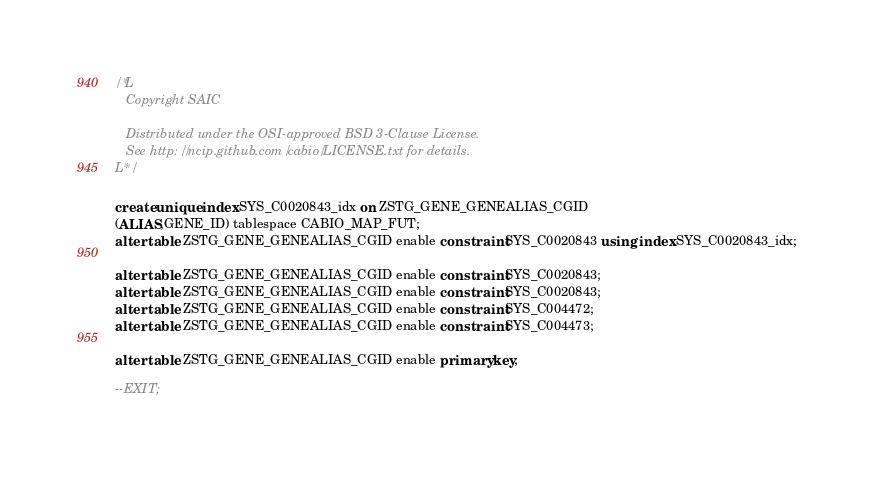<code> <loc_0><loc_0><loc_500><loc_500><_SQL_>/*L
   Copyright SAIC

   Distributed under the OSI-approved BSD 3-Clause License.
   See http://ncip.github.com/cabio/LICENSE.txt for details.
L*/

create unique index SYS_C0020843_idx on ZSTG_GENE_GENEALIAS_CGID
(ALIAS,GENE_ID) tablespace CABIO_MAP_FUT;
alter table ZSTG_GENE_GENEALIAS_CGID enable constraint SYS_C0020843 using index SYS_C0020843_idx;

alter table ZSTG_GENE_GENEALIAS_CGID enable constraint SYS_C0020843;
alter table ZSTG_GENE_GENEALIAS_CGID enable constraint SYS_C0020843;
alter table ZSTG_GENE_GENEALIAS_CGID enable constraint SYS_C004472;
alter table ZSTG_GENE_GENEALIAS_CGID enable constraint SYS_C004473;

alter table ZSTG_GENE_GENEALIAS_CGID enable primary key;

--EXIT;
</code> 